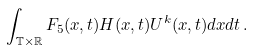<formula> <loc_0><loc_0><loc_500><loc_500>\int _ { \mathbb { T } \times \mathbb { R } } F _ { 5 } ( x , t ) H ( x , t ) U ^ { k } ( x , t ) d x d t \, .</formula> 